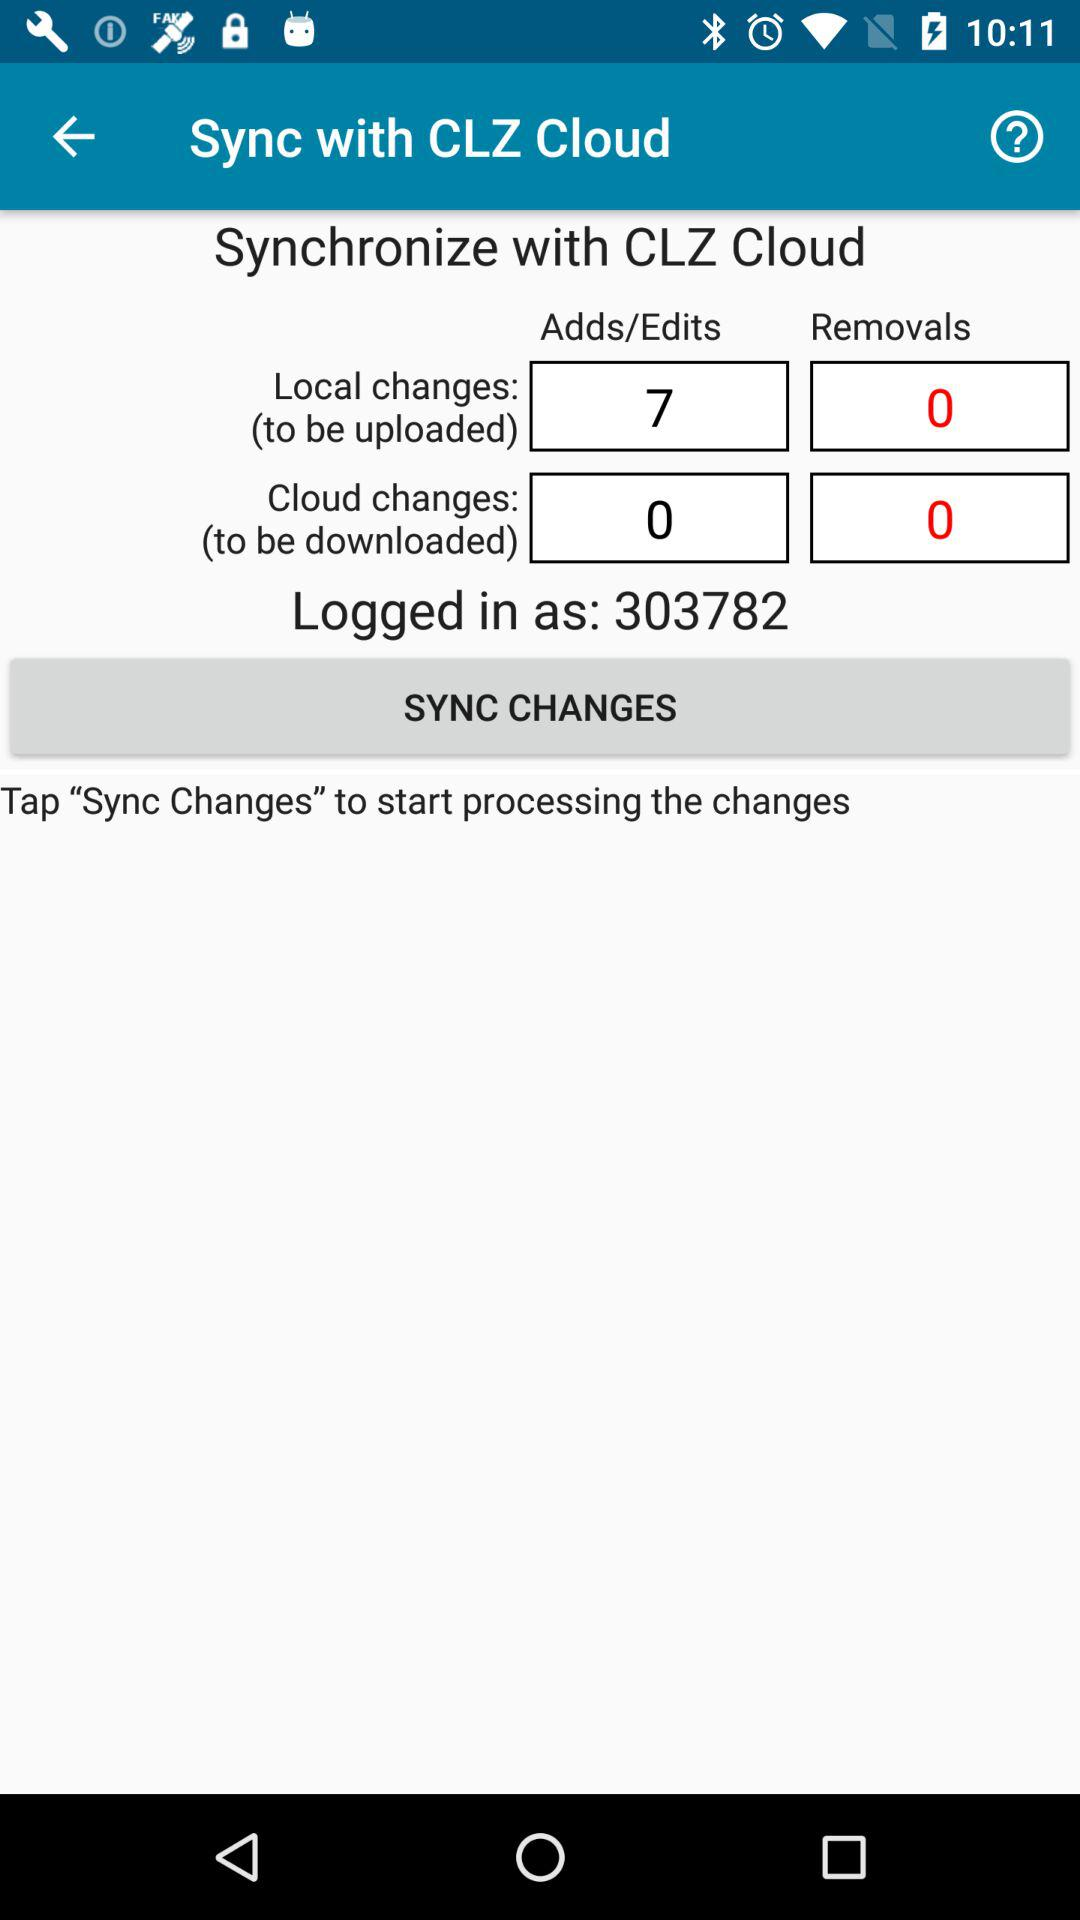What is the number of removals for cloud changes (to be downloaded)? The number of removals for cloud changes (to be downloaded) is 0. 